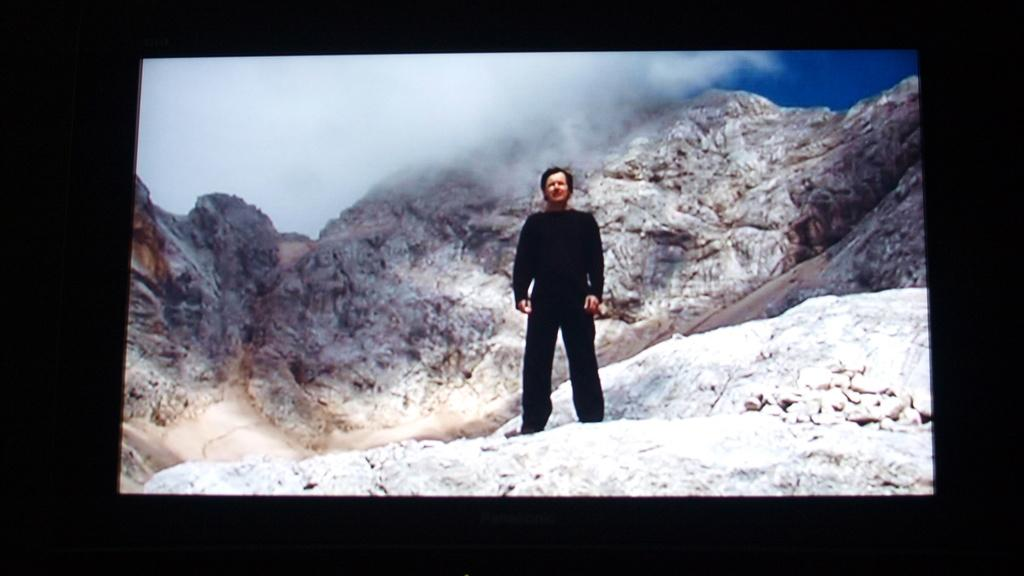What is the main subject of the image displayed on the screen? There is a man standing in the image. Can you describe the background of the image? The background of the image includes mountains and the sky. What can be seen in the sky in the image? Clouds are present in the sky in the image. What type of instrument is the man playing in the image? There is no instrument present in the image; the man is simply standing. Can you tell me how much milk the town in the image produces? There is no town or mention of milk production in the image; it features a man standing in front of mountains and a sky with clouds. 